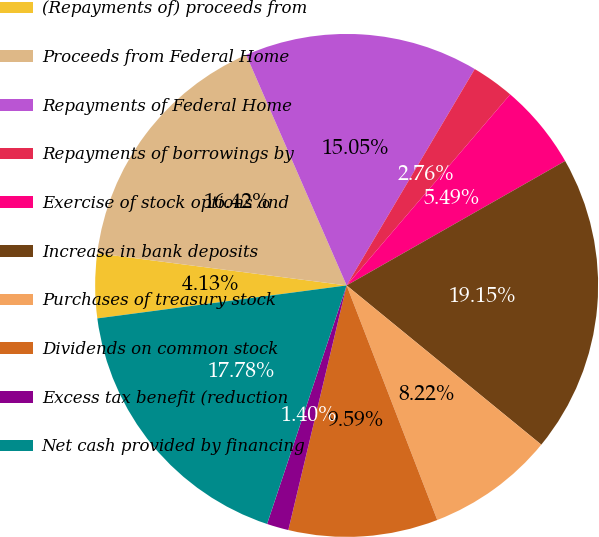Convert chart to OTSL. <chart><loc_0><loc_0><loc_500><loc_500><pie_chart><fcel>(Repayments of) proceeds from<fcel>Proceeds from Federal Home<fcel>Repayments of Federal Home<fcel>Repayments of borrowings by<fcel>Exercise of stock options and<fcel>Increase in bank deposits<fcel>Purchases of treasury stock<fcel>Dividends on common stock<fcel>Excess tax benefit (reduction<fcel>Net cash provided by financing<nl><fcel>4.13%<fcel>16.42%<fcel>15.05%<fcel>2.76%<fcel>5.49%<fcel>19.15%<fcel>8.22%<fcel>9.59%<fcel>1.4%<fcel>17.78%<nl></chart> 